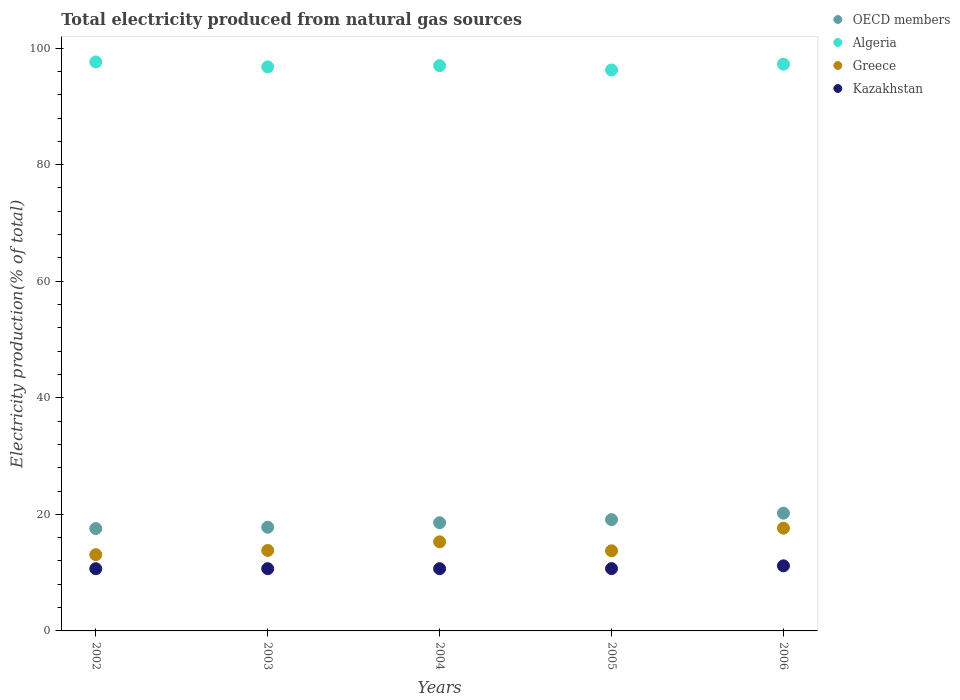What is the total electricity produced in Kazakhstan in 2005?
Provide a succinct answer. 10.69. Across all years, what is the maximum total electricity produced in OECD members?
Offer a terse response. 20.2. Across all years, what is the minimum total electricity produced in Algeria?
Offer a very short reply. 96.25. In which year was the total electricity produced in OECD members maximum?
Provide a succinct answer. 2006. In which year was the total electricity produced in Kazakhstan minimum?
Ensure brevity in your answer.  2002. What is the total total electricity produced in Algeria in the graph?
Your response must be concise. 484.92. What is the difference between the total electricity produced in Greece in 2005 and that in 2006?
Your answer should be very brief. -3.88. What is the difference between the total electricity produced in OECD members in 2006 and the total electricity produced in Kazakhstan in 2003?
Ensure brevity in your answer.  9.53. What is the average total electricity produced in Greece per year?
Keep it short and to the point. 14.71. In the year 2004, what is the difference between the total electricity produced in Greece and total electricity produced in OECD members?
Provide a succinct answer. -3.28. In how many years, is the total electricity produced in Greece greater than 64 %?
Make the answer very short. 0. What is the ratio of the total electricity produced in OECD members in 2005 to that in 2006?
Your response must be concise. 0.95. Is the difference between the total electricity produced in Greece in 2002 and 2003 greater than the difference between the total electricity produced in OECD members in 2002 and 2003?
Your response must be concise. No. What is the difference between the highest and the second highest total electricity produced in Greece?
Offer a very short reply. 2.34. What is the difference between the highest and the lowest total electricity produced in Kazakhstan?
Keep it short and to the point. 0.49. Is it the case that in every year, the sum of the total electricity produced in Kazakhstan and total electricity produced in Algeria  is greater than the sum of total electricity produced in OECD members and total electricity produced in Greece?
Provide a succinct answer. Yes. Does the total electricity produced in Greece monotonically increase over the years?
Give a very brief answer. No. Is the total electricity produced in Greece strictly less than the total electricity produced in Algeria over the years?
Your answer should be compact. Yes. How many dotlines are there?
Ensure brevity in your answer.  4. What is the difference between two consecutive major ticks on the Y-axis?
Make the answer very short. 20. Are the values on the major ticks of Y-axis written in scientific E-notation?
Your answer should be compact. No. Does the graph contain any zero values?
Keep it short and to the point. No. Where does the legend appear in the graph?
Your answer should be compact. Top right. What is the title of the graph?
Give a very brief answer. Total electricity produced from natural gas sources. Does "Singapore" appear as one of the legend labels in the graph?
Ensure brevity in your answer.  No. What is the label or title of the X-axis?
Your answer should be very brief. Years. What is the Electricity production(% of total) of OECD members in 2002?
Ensure brevity in your answer.  17.56. What is the Electricity production(% of total) in Algeria in 2002?
Provide a succinct answer. 97.63. What is the Electricity production(% of total) of Greece in 2002?
Ensure brevity in your answer.  13.09. What is the Electricity production(% of total) in Kazakhstan in 2002?
Your answer should be very brief. 10.68. What is the Electricity production(% of total) in OECD members in 2003?
Keep it short and to the point. 17.79. What is the Electricity production(% of total) in Algeria in 2003?
Keep it short and to the point. 96.78. What is the Electricity production(% of total) of Greece in 2003?
Offer a very short reply. 13.81. What is the Electricity production(% of total) in Kazakhstan in 2003?
Make the answer very short. 10.68. What is the Electricity production(% of total) of OECD members in 2004?
Offer a terse response. 18.57. What is the Electricity production(% of total) of Algeria in 2004?
Keep it short and to the point. 97. What is the Electricity production(% of total) in Greece in 2004?
Offer a terse response. 15.29. What is the Electricity production(% of total) in Kazakhstan in 2004?
Provide a succinct answer. 10.68. What is the Electricity production(% of total) in OECD members in 2005?
Provide a succinct answer. 19.1. What is the Electricity production(% of total) in Algeria in 2005?
Make the answer very short. 96.25. What is the Electricity production(% of total) of Greece in 2005?
Your answer should be very brief. 13.75. What is the Electricity production(% of total) in Kazakhstan in 2005?
Provide a succinct answer. 10.69. What is the Electricity production(% of total) of OECD members in 2006?
Offer a very short reply. 20.2. What is the Electricity production(% of total) of Algeria in 2006?
Your answer should be very brief. 97.25. What is the Electricity production(% of total) in Greece in 2006?
Ensure brevity in your answer.  17.63. What is the Electricity production(% of total) in Kazakhstan in 2006?
Give a very brief answer. 11.17. Across all years, what is the maximum Electricity production(% of total) in OECD members?
Offer a very short reply. 20.2. Across all years, what is the maximum Electricity production(% of total) of Algeria?
Ensure brevity in your answer.  97.63. Across all years, what is the maximum Electricity production(% of total) in Greece?
Your answer should be compact. 17.63. Across all years, what is the maximum Electricity production(% of total) of Kazakhstan?
Make the answer very short. 11.17. Across all years, what is the minimum Electricity production(% of total) of OECD members?
Ensure brevity in your answer.  17.56. Across all years, what is the minimum Electricity production(% of total) in Algeria?
Ensure brevity in your answer.  96.25. Across all years, what is the minimum Electricity production(% of total) in Greece?
Offer a terse response. 13.09. Across all years, what is the minimum Electricity production(% of total) of Kazakhstan?
Your answer should be very brief. 10.68. What is the total Electricity production(% of total) of OECD members in the graph?
Provide a short and direct response. 93.23. What is the total Electricity production(% of total) of Algeria in the graph?
Provide a short and direct response. 484.92. What is the total Electricity production(% of total) of Greece in the graph?
Your response must be concise. 73.56. What is the total Electricity production(% of total) of Kazakhstan in the graph?
Offer a terse response. 53.89. What is the difference between the Electricity production(% of total) of OECD members in 2002 and that in 2003?
Your response must be concise. -0.23. What is the difference between the Electricity production(% of total) of Algeria in 2002 and that in 2003?
Offer a very short reply. 0.85. What is the difference between the Electricity production(% of total) of Greece in 2002 and that in 2003?
Your answer should be very brief. -0.72. What is the difference between the Electricity production(% of total) in Kazakhstan in 2002 and that in 2003?
Your answer should be very brief. -0. What is the difference between the Electricity production(% of total) of OECD members in 2002 and that in 2004?
Provide a succinct answer. -1. What is the difference between the Electricity production(% of total) of Algeria in 2002 and that in 2004?
Ensure brevity in your answer.  0.64. What is the difference between the Electricity production(% of total) in Greece in 2002 and that in 2004?
Provide a succinct answer. -2.2. What is the difference between the Electricity production(% of total) in Kazakhstan in 2002 and that in 2004?
Offer a very short reply. -0. What is the difference between the Electricity production(% of total) in OECD members in 2002 and that in 2005?
Make the answer very short. -1.54. What is the difference between the Electricity production(% of total) in Algeria in 2002 and that in 2005?
Keep it short and to the point. 1.39. What is the difference between the Electricity production(% of total) of Greece in 2002 and that in 2005?
Give a very brief answer. -0.66. What is the difference between the Electricity production(% of total) of Kazakhstan in 2002 and that in 2005?
Make the answer very short. -0.01. What is the difference between the Electricity production(% of total) of OECD members in 2002 and that in 2006?
Keep it short and to the point. -2.64. What is the difference between the Electricity production(% of total) of Algeria in 2002 and that in 2006?
Offer a very short reply. 0.38. What is the difference between the Electricity production(% of total) in Greece in 2002 and that in 2006?
Make the answer very short. -4.54. What is the difference between the Electricity production(% of total) of Kazakhstan in 2002 and that in 2006?
Give a very brief answer. -0.49. What is the difference between the Electricity production(% of total) of OECD members in 2003 and that in 2004?
Ensure brevity in your answer.  -0.77. What is the difference between the Electricity production(% of total) in Algeria in 2003 and that in 2004?
Provide a succinct answer. -0.22. What is the difference between the Electricity production(% of total) in Greece in 2003 and that in 2004?
Your answer should be compact. -1.48. What is the difference between the Electricity production(% of total) of Kazakhstan in 2003 and that in 2004?
Your response must be concise. -0. What is the difference between the Electricity production(% of total) of OECD members in 2003 and that in 2005?
Your response must be concise. -1.3. What is the difference between the Electricity production(% of total) of Algeria in 2003 and that in 2005?
Your response must be concise. 0.53. What is the difference between the Electricity production(% of total) in Greece in 2003 and that in 2005?
Provide a short and direct response. 0.06. What is the difference between the Electricity production(% of total) in Kazakhstan in 2003 and that in 2005?
Your answer should be compact. -0.01. What is the difference between the Electricity production(% of total) of OECD members in 2003 and that in 2006?
Provide a short and direct response. -2.41. What is the difference between the Electricity production(% of total) in Algeria in 2003 and that in 2006?
Your answer should be compact. -0.47. What is the difference between the Electricity production(% of total) in Greece in 2003 and that in 2006?
Offer a very short reply. -3.82. What is the difference between the Electricity production(% of total) of Kazakhstan in 2003 and that in 2006?
Offer a terse response. -0.49. What is the difference between the Electricity production(% of total) of OECD members in 2004 and that in 2005?
Provide a short and direct response. -0.53. What is the difference between the Electricity production(% of total) in Algeria in 2004 and that in 2005?
Offer a very short reply. 0.75. What is the difference between the Electricity production(% of total) in Greece in 2004 and that in 2005?
Offer a very short reply. 1.54. What is the difference between the Electricity production(% of total) of Kazakhstan in 2004 and that in 2005?
Make the answer very short. -0.01. What is the difference between the Electricity production(% of total) of OECD members in 2004 and that in 2006?
Ensure brevity in your answer.  -1.64. What is the difference between the Electricity production(% of total) of Algeria in 2004 and that in 2006?
Offer a terse response. -0.25. What is the difference between the Electricity production(% of total) of Greece in 2004 and that in 2006?
Your response must be concise. -2.34. What is the difference between the Electricity production(% of total) in Kazakhstan in 2004 and that in 2006?
Ensure brevity in your answer.  -0.49. What is the difference between the Electricity production(% of total) in OECD members in 2005 and that in 2006?
Provide a succinct answer. -1.11. What is the difference between the Electricity production(% of total) in Algeria in 2005 and that in 2006?
Provide a succinct answer. -1. What is the difference between the Electricity production(% of total) of Greece in 2005 and that in 2006?
Keep it short and to the point. -3.88. What is the difference between the Electricity production(% of total) in Kazakhstan in 2005 and that in 2006?
Your answer should be very brief. -0.48. What is the difference between the Electricity production(% of total) in OECD members in 2002 and the Electricity production(% of total) in Algeria in 2003?
Your answer should be very brief. -79.22. What is the difference between the Electricity production(% of total) of OECD members in 2002 and the Electricity production(% of total) of Greece in 2003?
Provide a short and direct response. 3.76. What is the difference between the Electricity production(% of total) of OECD members in 2002 and the Electricity production(% of total) of Kazakhstan in 2003?
Provide a short and direct response. 6.89. What is the difference between the Electricity production(% of total) in Algeria in 2002 and the Electricity production(% of total) in Greece in 2003?
Give a very brief answer. 83.83. What is the difference between the Electricity production(% of total) of Algeria in 2002 and the Electricity production(% of total) of Kazakhstan in 2003?
Your answer should be very brief. 86.96. What is the difference between the Electricity production(% of total) of Greece in 2002 and the Electricity production(% of total) of Kazakhstan in 2003?
Your answer should be compact. 2.41. What is the difference between the Electricity production(% of total) in OECD members in 2002 and the Electricity production(% of total) in Algeria in 2004?
Provide a short and direct response. -79.43. What is the difference between the Electricity production(% of total) in OECD members in 2002 and the Electricity production(% of total) in Greece in 2004?
Your answer should be very brief. 2.28. What is the difference between the Electricity production(% of total) of OECD members in 2002 and the Electricity production(% of total) of Kazakhstan in 2004?
Ensure brevity in your answer.  6.88. What is the difference between the Electricity production(% of total) in Algeria in 2002 and the Electricity production(% of total) in Greece in 2004?
Ensure brevity in your answer.  82.35. What is the difference between the Electricity production(% of total) in Algeria in 2002 and the Electricity production(% of total) in Kazakhstan in 2004?
Ensure brevity in your answer.  86.96. What is the difference between the Electricity production(% of total) of Greece in 2002 and the Electricity production(% of total) of Kazakhstan in 2004?
Offer a very short reply. 2.41. What is the difference between the Electricity production(% of total) in OECD members in 2002 and the Electricity production(% of total) in Algeria in 2005?
Your response must be concise. -78.69. What is the difference between the Electricity production(% of total) of OECD members in 2002 and the Electricity production(% of total) of Greece in 2005?
Your answer should be very brief. 3.81. What is the difference between the Electricity production(% of total) of OECD members in 2002 and the Electricity production(% of total) of Kazakhstan in 2005?
Provide a short and direct response. 6.87. What is the difference between the Electricity production(% of total) of Algeria in 2002 and the Electricity production(% of total) of Greece in 2005?
Your answer should be compact. 83.88. What is the difference between the Electricity production(% of total) in Algeria in 2002 and the Electricity production(% of total) in Kazakhstan in 2005?
Give a very brief answer. 86.94. What is the difference between the Electricity production(% of total) in Greece in 2002 and the Electricity production(% of total) in Kazakhstan in 2005?
Make the answer very short. 2.4. What is the difference between the Electricity production(% of total) in OECD members in 2002 and the Electricity production(% of total) in Algeria in 2006?
Keep it short and to the point. -79.69. What is the difference between the Electricity production(% of total) of OECD members in 2002 and the Electricity production(% of total) of Greece in 2006?
Provide a short and direct response. -0.07. What is the difference between the Electricity production(% of total) of OECD members in 2002 and the Electricity production(% of total) of Kazakhstan in 2006?
Give a very brief answer. 6.4. What is the difference between the Electricity production(% of total) of Algeria in 2002 and the Electricity production(% of total) of Greece in 2006?
Your answer should be compact. 80. What is the difference between the Electricity production(% of total) in Algeria in 2002 and the Electricity production(% of total) in Kazakhstan in 2006?
Provide a succinct answer. 86.47. What is the difference between the Electricity production(% of total) in Greece in 2002 and the Electricity production(% of total) in Kazakhstan in 2006?
Make the answer very short. 1.92. What is the difference between the Electricity production(% of total) of OECD members in 2003 and the Electricity production(% of total) of Algeria in 2004?
Make the answer very short. -79.2. What is the difference between the Electricity production(% of total) in OECD members in 2003 and the Electricity production(% of total) in Greece in 2004?
Keep it short and to the point. 2.51. What is the difference between the Electricity production(% of total) in OECD members in 2003 and the Electricity production(% of total) in Kazakhstan in 2004?
Ensure brevity in your answer.  7.12. What is the difference between the Electricity production(% of total) in Algeria in 2003 and the Electricity production(% of total) in Greece in 2004?
Keep it short and to the point. 81.49. What is the difference between the Electricity production(% of total) in Algeria in 2003 and the Electricity production(% of total) in Kazakhstan in 2004?
Provide a short and direct response. 86.1. What is the difference between the Electricity production(% of total) of Greece in 2003 and the Electricity production(% of total) of Kazakhstan in 2004?
Provide a short and direct response. 3.13. What is the difference between the Electricity production(% of total) in OECD members in 2003 and the Electricity production(% of total) in Algeria in 2005?
Your response must be concise. -78.46. What is the difference between the Electricity production(% of total) of OECD members in 2003 and the Electricity production(% of total) of Greece in 2005?
Offer a terse response. 4.04. What is the difference between the Electricity production(% of total) of OECD members in 2003 and the Electricity production(% of total) of Kazakhstan in 2005?
Your response must be concise. 7.1. What is the difference between the Electricity production(% of total) in Algeria in 2003 and the Electricity production(% of total) in Greece in 2005?
Offer a very short reply. 83.03. What is the difference between the Electricity production(% of total) in Algeria in 2003 and the Electricity production(% of total) in Kazakhstan in 2005?
Your answer should be very brief. 86.09. What is the difference between the Electricity production(% of total) of Greece in 2003 and the Electricity production(% of total) of Kazakhstan in 2005?
Provide a short and direct response. 3.12. What is the difference between the Electricity production(% of total) of OECD members in 2003 and the Electricity production(% of total) of Algeria in 2006?
Offer a terse response. -79.46. What is the difference between the Electricity production(% of total) in OECD members in 2003 and the Electricity production(% of total) in Greece in 2006?
Provide a succinct answer. 0.16. What is the difference between the Electricity production(% of total) in OECD members in 2003 and the Electricity production(% of total) in Kazakhstan in 2006?
Provide a short and direct response. 6.63. What is the difference between the Electricity production(% of total) in Algeria in 2003 and the Electricity production(% of total) in Greece in 2006?
Offer a very short reply. 79.15. What is the difference between the Electricity production(% of total) in Algeria in 2003 and the Electricity production(% of total) in Kazakhstan in 2006?
Give a very brief answer. 85.61. What is the difference between the Electricity production(% of total) in Greece in 2003 and the Electricity production(% of total) in Kazakhstan in 2006?
Give a very brief answer. 2.64. What is the difference between the Electricity production(% of total) in OECD members in 2004 and the Electricity production(% of total) in Algeria in 2005?
Keep it short and to the point. -77.68. What is the difference between the Electricity production(% of total) of OECD members in 2004 and the Electricity production(% of total) of Greece in 2005?
Your answer should be very brief. 4.82. What is the difference between the Electricity production(% of total) in OECD members in 2004 and the Electricity production(% of total) in Kazakhstan in 2005?
Keep it short and to the point. 7.88. What is the difference between the Electricity production(% of total) of Algeria in 2004 and the Electricity production(% of total) of Greece in 2005?
Keep it short and to the point. 83.25. What is the difference between the Electricity production(% of total) in Algeria in 2004 and the Electricity production(% of total) in Kazakhstan in 2005?
Offer a very short reply. 86.31. What is the difference between the Electricity production(% of total) of Greece in 2004 and the Electricity production(% of total) of Kazakhstan in 2005?
Provide a succinct answer. 4.6. What is the difference between the Electricity production(% of total) of OECD members in 2004 and the Electricity production(% of total) of Algeria in 2006?
Ensure brevity in your answer.  -78.69. What is the difference between the Electricity production(% of total) in OECD members in 2004 and the Electricity production(% of total) in Greece in 2006?
Make the answer very short. 0.94. What is the difference between the Electricity production(% of total) of OECD members in 2004 and the Electricity production(% of total) of Kazakhstan in 2006?
Ensure brevity in your answer.  7.4. What is the difference between the Electricity production(% of total) in Algeria in 2004 and the Electricity production(% of total) in Greece in 2006?
Your answer should be very brief. 79.37. What is the difference between the Electricity production(% of total) in Algeria in 2004 and the Electricity production(% of total) in Kazakhstan in 2006?
Make the answer very short. 85.83. What is the difference between the Electricity production(% of total) in Greece in 2004 and the Electricity production(% of total) in Kazakhstan in 2006?
Provide a succinct answer. 4.12. What is the difference between the Electricity production(% of total) in OECD members in 2005 and the Electricity production(% of total) in Algeria in 2006?
Ensure brevity in your answer.  -78.15. What is the difference between the Electricity production(% of total) in OECD members in 2005 and the Electricity production(% of total) in Greece in 2006?
Your answer should be compact. 1.47. What is the difference between the Electricity production(% of total) in OECD members in 2005 and the Electricity production(% of total) in Kazakhstan in 2006?
Offer a terse response. 7.93. What is the difference between the Electricity production(% of total) in Algeria in 2005 and the Electricity production(% of total) in Greece in 2006?
Give a very brief answer. 78.62. What is the difference between the Electricity production(% of total) in Algeria in 2005 and the Electricity production(% of total) in Kazakhstan in 2006?
Offer a very short reply. 85.08. What is the difference between the Electricity production(% of total) of Greece in 2005 and the Electricity production(% of total) of Kazakhstan in 2006?
Ensure brevity in your answer.  2.58. What is the average Electricity production(% of total) of OECD members per year?
Provide a succinct answer. 18.65. What is the average Electricity production(% of total) in Algeria per year?
Offer a very short reply. 96.98. What is the average Electricity production(% of total) in Greece per year?
Your answer should be compact. 14.71. What is the average Electricity production(% of total) in Kazakhstan per year?
Offer a terse response. 10.78. In the year 2002, what is the difference between the Electricity production(% of total) in OECD members and Electricity production(% of total) in Algeria?
Offer a very short reply. -80.07. In the year 2002, what is the difference between the Electricity production(% of total) of OECD members and Electricity production(% of total) of Greece?
Ensure brevity in your answer.  4.47. In the year 2002, what is the difference between the Electricity production(% of total) of OECD members and Electricity production(% of total) of Kazakhstan?
Your response must be concise. 6.89. In the year 2002, what is the difference between the Electricity production(% of total) of Algeria and Electricity production(% of total) of Greece?
Your answer should be compact. 84.55. In the year 2002, what is the difference between the Electricity production(% of total) in Algeria and Electricity production(% of total) in Kazakhstan?
Your answer should be compact. 86.96. In the year 2002, what is the difference between the Electricity production(% of total) of Greece and Electricity production(% of total) of Kazakhstan?
Offer a terse response. 2.41. In the year 2003, what is the difference between the Electricity production(% of total) of OECD members and Electricity production(% of total) of Algeria?
Ensure brevity in your answer.  -78.99. In the year 2003, what is the difference between the Electricity production(% of total) in OECD members and Electricity production(% of total) in Greece?
Provide a short and direct response. 3.99. In the year 2003, what is the difference between the Electricity production(% of total) of OECD members and Electricity production(% of total) of Kazakhstan?
Ensure brevity in your answer.  7.12. In the year 2003, what is the difference between the Electricity production(% of total) of Algeria and Electricity production(% of total) of Greece?
Your answer should be very brief. 82.97. In the year 2003, what is the difference between the Electricity production(% of total) in Algeria and Electricity production(% of total) in Kazakhstan?
Your answer should be very brief. 86.1. In the year 2003, what is the difference between the Electricity production(% of total) in Greece and Electricity production(% of total) in Kazakhstan?
Ensure brevity in your answer.  3.13. In the year 2004, what is the difference between the Electricity production(% of total) in OECD members and Electricity production(% of total) in Algeria?
Your answer should be very brief. -78.43. In the year 2004, what is the difference between the Electricity production(% of total) in OECD members and Electricity production(% of total) in Greece?
Provide a succinct answer. 3.28. In the year 2004, what is the difference between the Electricity production(% of total) in OECD members and Electricity production(% of total) in Kazakhstan?
Make the answer very short. 7.89. In the year 2004, what is the difference between the Electricity production(% of total) of Algeria and Electricity production(% of total) of Greece?
Your response must be concise. 81.71. In the year 2004, what is the difference between the Electricity production(% of total) in Algeria and Electricity production(% of total) in Kazakhstan?
Ensure brevity in your answer.  86.32. In the year 2004, what is the difference between the Electricity production(% of total) in Greece and Electricity production(% of total) in Kazakhstan?
Provide a succinct answer. 4.61. In the year 2005, what is the difference between the Electricity production(% of total) of OECD members and Electricity production(% of total) of Algeria?
Make the answer very short. -77.15. In the year 2005, what is the difference between the Electricity production(% of total) of OECD members and Electricity production(% of total) of Greece?
Ensure brevity in your answer.  5.35. In the year 2005, what is the difference between the Electricity production(% of total) in OECD members and Electricity production(% of total) in Kazakhstan?
Provide a short and direct response. 8.41. In the year 2005, what is the difference between the Electricity production(% of total) of Algeria and Electricity production(% of total) of Greece?
Make the answer very short. 82.5. In the year 2005, what is the difference between the Electricity production(% of total) in Algeria and Electricity production(% of total) in Kazakhstan?
Make the answer very short. 85.56. In the year 2005, what is the difference between the Electricity production(% of total) of Greece and Electricity production(% of total) of Kazakhstan?
Your response must be concise. 3.06. In the year 2006, what is the difference between the Electricity production(% of total) in OECD members and Electricity production(% of total) in Algeria?
Provide a succinct answer. -77.05. In the year 2006, what is the difference between the Electricity production(% of total) of OECD members and Electricity production(% of total) of Greece?
Provide a short and direct response. 2.57. In the year 2006, what is the difference between the Electricity production(% of total) of OECD members and Electricity production(% of total) of Kazakhstan?
Provide a short and direct response. 9.04. In the year 2006, what is the difference between the Electricity production(% of total) of Algeria and Electricity production(% of total) of Greece?
Make the answer very short. 79.62. In the year 2006, what is the difference between the Electricity production(% of total) in Algeria and Electricity production(% of total) in Kazakhstan?
Your response must be concise. 86.08. In the year 2006, what is the difference between the Electricity production(% of total) in Greece and Electricity production(% of total) in Kazakhstan?
Your response must be concise. 6.46. What is the ratio of the Electricity production(% of total) of OECD members in 2002 to that in 2003?
Offer a terse response. 0.99. What is the ratio of the Electricity production(% of total) of Algeria in 2002 to that in 2003?
Offer a terse response. 1.01. What is the ratio of the Electricity production(% of total) in Greece in 2002 to that in 2003?
Provide a short and direct response. 0.95. What is the ratio of the Electricity production(% of total) of Kazakhstan in 2002 to that in 2003?
Your response must be concise. 1. What is the ratio of the Electricity production(% of total) in OECD members in 2002 to that in 2004?
Give a very brief answer. 0.95. What is the ratio of the Electricity production(% of total) in Algeria in 2002 to that in 2004?
Your answer should be compact. 1.01. What is the ratio of the Electricity production(% of total) in Greece in 2002 to that in 2004?
Your response must be concise. 0.86. What is the ratio of the Electricity production(% of total) in OECD members in 2002 to that in 2005?
Offer a very short reply. 0.92. What is the ratio of the Electricity production(% of total) of Algeria in 2002 to that in 2005?
Ensure brevity in your answer.  1.01. What is the ratio of the Electricity production(% of total) of Kazakhstan in 2002 to that in 2005?
Give a very brief answer. 1. What is the ratio of the Electricity production(% of total) in OECD members in 2002 to that in 2006?
Make the answer very short. 0.87. What is the ratio of the Electricity production(% of total) of Algeria in 2002 to that in 2006?
Give a very brief answer. 1. What is the ratio of the Electricity production(% of total) in Greece in 2002 to that in 2006?
Keep it short and to the point. 0.74. What is the ratio of the Electricity production(% of total) of Kazakhstan in 2002 to that in 2006?
Provide a succinct answer. 0.96. What is the ratio of the Electricity production(% of total) in OECD members in 2003 to that in 2004?
Your response must be concise. 0.96. What is the ratio of the Electricity production(% of total) of Greece in 2003 to that in 2004?
Provide a short and direct response. 0.9. What is the ratio of the Electricity production(% of total) of Kazakhstan in 2003 to that in 2004?
Offer a terse response. 1. What is the ratio of the Electricity production(% of total) of OECD members in 2003 to that in 2005?
Keep it short and to the point. 0.93. What is the ratio of the Electricity production(% of total) in OECD members in 2003 to that in 2006?
Ensure brevity in your answer.  0.88. What is the ratio of the Electricity production(% of total) of Greece in 2003 to that in 2006?
Your answer should be compact. 0.78. What is the ratio of the Electricity production(% of total) of Kazakhstan in 2003 to that in 2006?
Give a very brief answer. 0.96. What is the ratio of the Electricity production(% of total) in OECD members in 2004 to that in 2005?
Your answer should be very brief. 0.97. What is the ratio of the Electricity production(% of total) in Greece in 2004 to that in 2005?
Offer a terse response. 1.11. What is the ratio of the Electricity production(% of total) of OECD members in 2004 to that in 2006?
Ensure brevity in your answer.  0.92. What is the ratio of the Electricity production(% of total) in Greece in 2004 to that in 2006?
Make the answer very short. 0.87. What is the ratio of the Electricity production(% of total) in Kazakhstan in 2004 to that in 2006?
Provide a succinct answer. 0.96. What is the ratio of the Electricity production(% of total) in OECD members in 2005 to that in 2006?
Your answer should be very brief. 0.95. What is the ratio of the Electricity production(% of total) of Algeria in 2005 to that in 2006?
Your answer should be very brief. 0.99. What is the ratio of the Electricity production(% of total) in Greece in 2005 to that in 2006?
Keep it short and to the point. 0.78. What is the ratio of the Electricity production(% of total) in Kazakhstan in 2005 to that in 2006?
Keep it short and to the point. 0.96. What is the difference between the highest and the second highest Electricity production(% of total) in OECD members?
Your answer should be compact. 1.11. What is the difference between the highest and the second highest Electricity production(% of total) in Algeria?
Offer a terse response. 0.38. What is the difference between the highest and the second highest Electricity production(% of total) in Greece?
Your response must be concise. 2.34. What is the difference between the highest and the second highest Electricity production(% of total) of Kazakhstan?
Your response must be concise. 0.48. What is the difference between the highest and the lowest Electricity production(% of total) in OECD members?
Your response must be concise. 2.64. What is the difference between the highest and the lowest Electricity production(% of total) in Algeria?
Offer a very short reply. 1.39. What is the difference between the highest and the lowest Electricity production(% of total) of Greece?
Your response must be concise. 4.54. What is the difference between the highest and the lowest Electricity production(% of total) of Kazakhstan?
Keep it short and to the point. 0.49. 